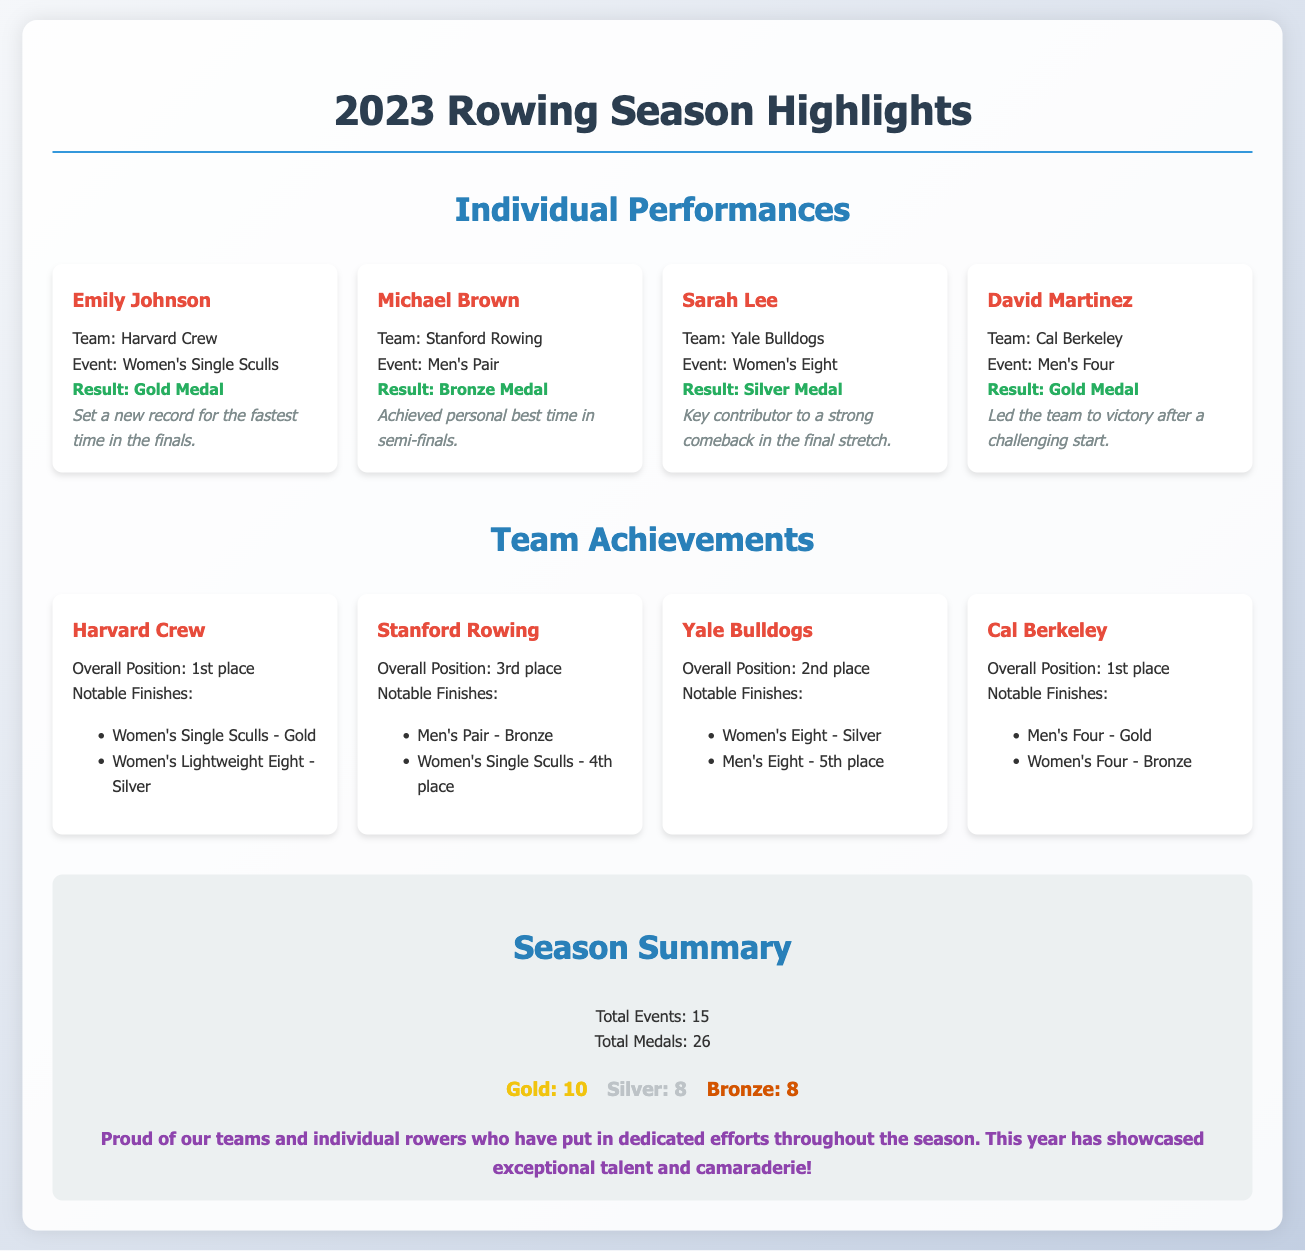What event did Emily Johnson compete in? Emily Johnson's event is specifically listed in the document under Individual Performances.
Answer: Women's Single Sculls Which team achieved a gold medal in Men's Four? The team and event with a gold medal are mentioned in the Team Achievements section.
Answer: Cal Berkeley How many total events were there in the 2023 rowing season? The total events count is explicitly stated in the Season Summary section.
Answer: 15 What overall position did Yale Bulldogs finish? Yale Bulldogs' overall position is noted in the Team Achievements section.
Answer: 2nd place Who is acknowledged as the key contributor in the Women's Eight event? The document specifies which individual was a key contributor in the Women's Eight event under Individual Performances.
Answer: Sarah Lee What was the total count of medals awarded in the 2023 rowing season? The total medals count is clearly mentioned in the Season Summary section.
Answer: 26 Which team had notable finishes in both Women's Single Sculls and Women's Lightweight Eight? The team with these notable finishes is explicitly listed in the Team Achievements.
Answer: Harvard Crew What accomplishment did David Martinez achieve during the race? The document mentions David Martinez's achievement in terms of his performance in the event.
Answer: Led the team to victory How many gold medals were won in the season? The number of gold medals is stated as part of the Season Summary.
Answer: 10 